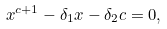Convert formula to latex. <formula><loc_0><loc_0><loc_500><loc_500>x ^ { c + 1 } - \delta _ { 1 } x - \delta _ { 2 } c = 0 ,</formula> 